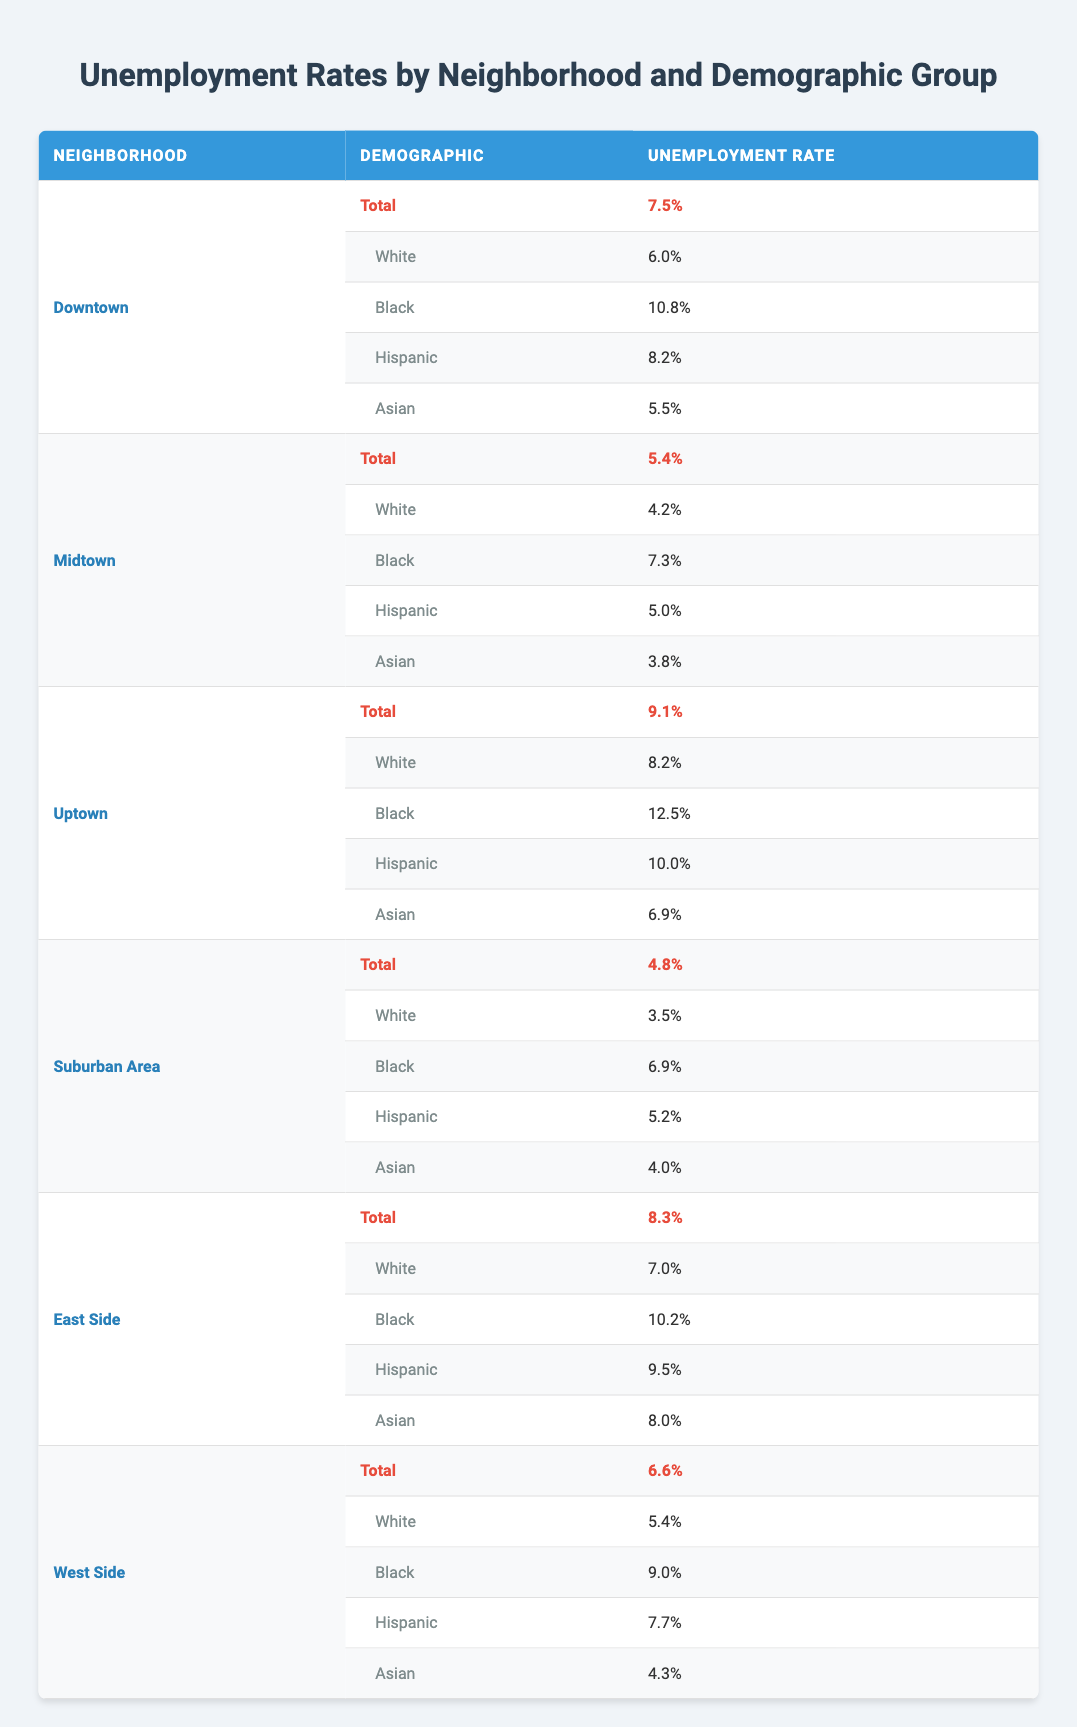What is the unemployment rate in Uptown? The table shows that the total unemployment rate in Uptown is listed directly under the total row for that neighborhood. It reads as 9.1%.
Answer: 9.1% Which demographic group has the highest unemployment rate in Downtown? Looking at the demographic rates in Downtown, the unemployment rates for each group are listed: White at 6.0%, Black at 10.8%, Hispanic at 8.2%, and Asian at 5.5%. The highest rate among these is for the Black demographic at 10.8%.
Answer: Black: 10.8% Is the unemployment rate for Hispanic residents in Midtown higher than 5%? In Midtown, the unemployment rate for Hispanics is 5.0%, which is not greater than 5%. The answer is therefore no.
Answer: No What is the average unemployment rate for Black residents across all neighborhoods? To find the average rate for Black residents, we sum the individual rates: 10.8% (Downtown) + 7.3% (Midtown) + 12.5% (Uptown) + 6.9% (Suburban Area) + 10.2% (East Side) + 9.0% (West Side) = 56.7%. There are 6 neighborhoods, so the average is 56.7% / 6 = 9.45%.
Answer: 9.45% Which neighborhood has the lowest total unemployment rate? From the total unemployment rates listed for each neighborhood, we find: Downtown 7.5%, Midtown 5.4%, Uptown 9.1%, Suburban Area 4.8%, East Side 8.3%, and West Side 6.6%. The lowest total rate is 4.8% in the Suburban Area.
Answer: Suburban Area: 4.8% Do White residents in Midtown have a lower unemployment rate than those in Downton? The unemployment rate for White residents in Midtown is 4.2%, while in Downtown, it is 6.0%. Since 4.2% is less than 6.0%, the answer is yes.
Answer: Yes What is the difference in unemployment rates between Black residents in Uptown and White residents in Suburban Area? The unemployment rate for Black residents in Uptown is 12.5%, and for White residents in the Suburban Area, it is 3.5%. The difference is 12.5% - 3.5% = 9.0%.
Answer: 9.0% 